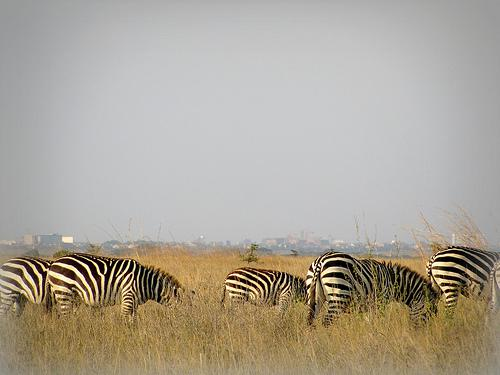Question: when is this?
Choices:
A. During the day.
B. Night time.
C. Dawn.
D. Dusk.
Answer with the letter. Answer: A Question: how many zebras are there?
Choices:
A. Four.
B. Five.
C. Six.
D. Seven.
Answer with the letter. Answer: B Question: why are the zebras bent over?
Choices:
A. They are resting.
B. Looking at the baby.
C. They are hurt.
D. The zebras are eating.
Answer with the letter. Answer: D Question: where is the city?
Choices:
A. Beyond the village.
B. In the markets.
C. Behind the field.
D. Past the bus.
Answer with the letter. Answer: C Question: what color are the zebras?
Choices:
A. Black and white.
B. Black.
C. White.
D. Red.
Answer with the letter. Answer: A Question: what animals are shown?
Choices:
A. Giraffes.
B. Bears.
C. Lions.
D. Zebras.
Answer with the letter. Answer: D Question: what are the zebras eating?
Choices:
A. Ground meal.
B. Grass.
C. Meat.
D. Leaves.
Answer with the letter. Answer: B 